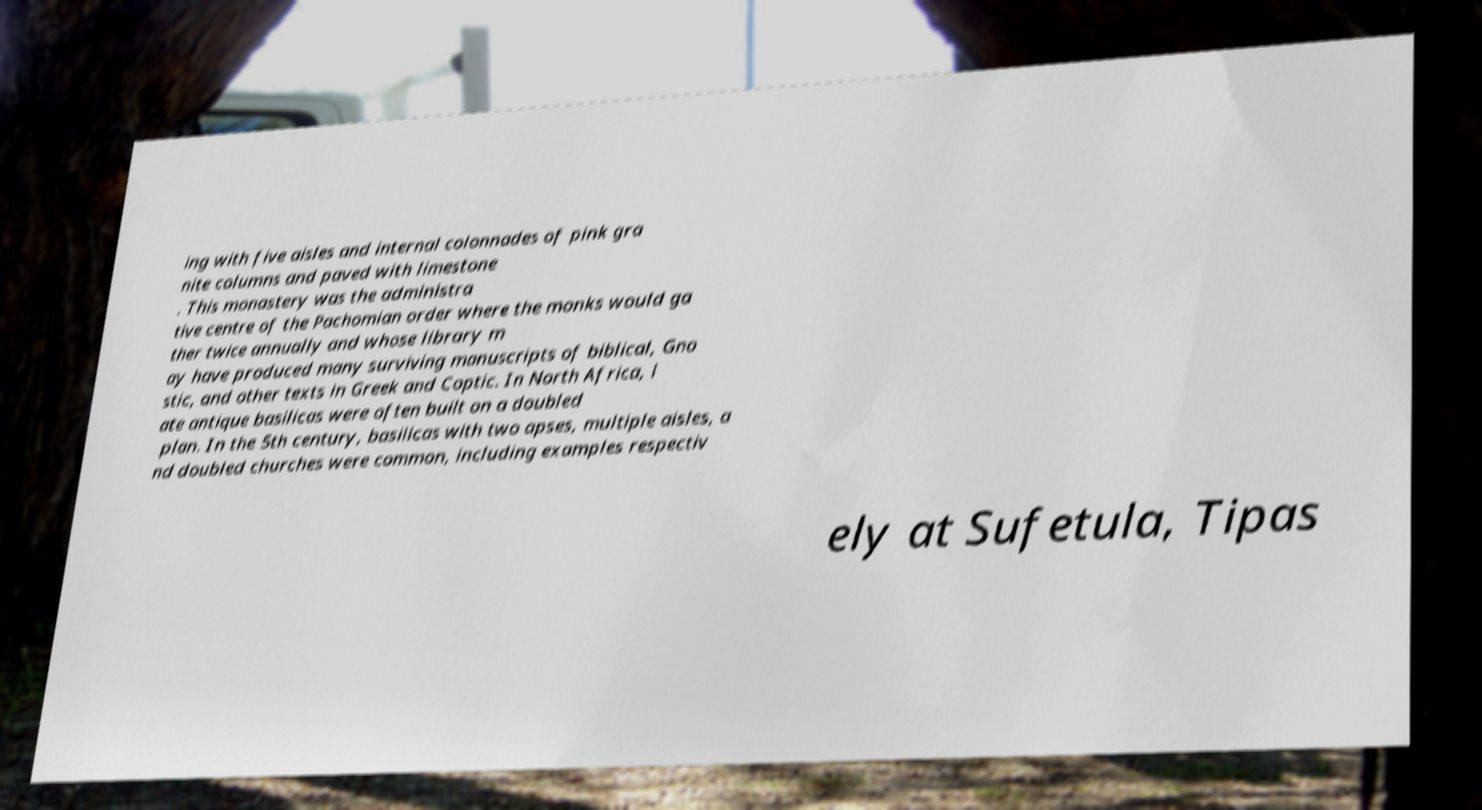Could you assist in decoding the text presented in this image and type it out clearly? ing with five aisles and internal colonnades of pink gra nite columns and paved with limestone . This monastery was the administra tive centre of the Pachomian order where the monks would ga ther twice annually and whose library m ay have produced many surviving manuscripts of biblical, Gno stic, and other texts in Greek and Coptic. In North Africa, l ate antique basilicas were often built on a doubled plan. In the 5th century, basilicas with two apses, multiple aisles, a nd doubled churches were common, including examples respectiv ely at Sufetula, Tipas 